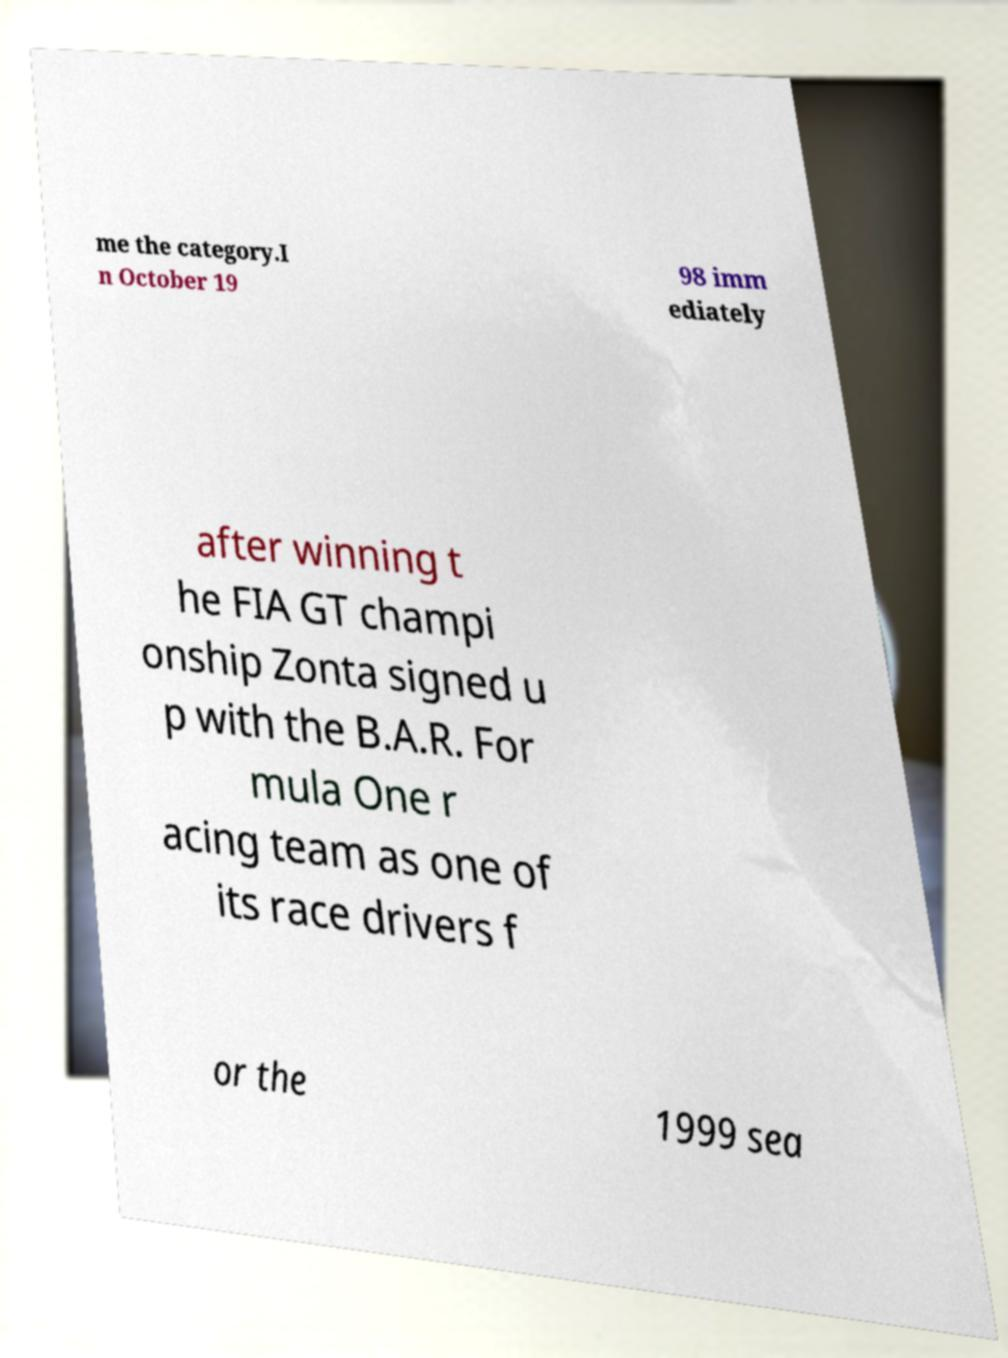There's text embedded in this image that I need extracted. Can you transcribe it verbatim? me the category.I n October 19 98 imm ediately after winning t he FIA GT champi onship Zonta signed u p with the B.A.R. For mula One r acing team as one of its race drivers f or the 1999 sea 